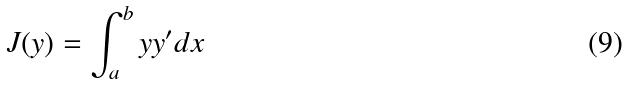Convert formula to latex. <formula><loc_0><loc_0><loc_500><loc_500>J ( y ) = \int _ { a } ^ { b } y y ^ { \prime } d x</formula> 